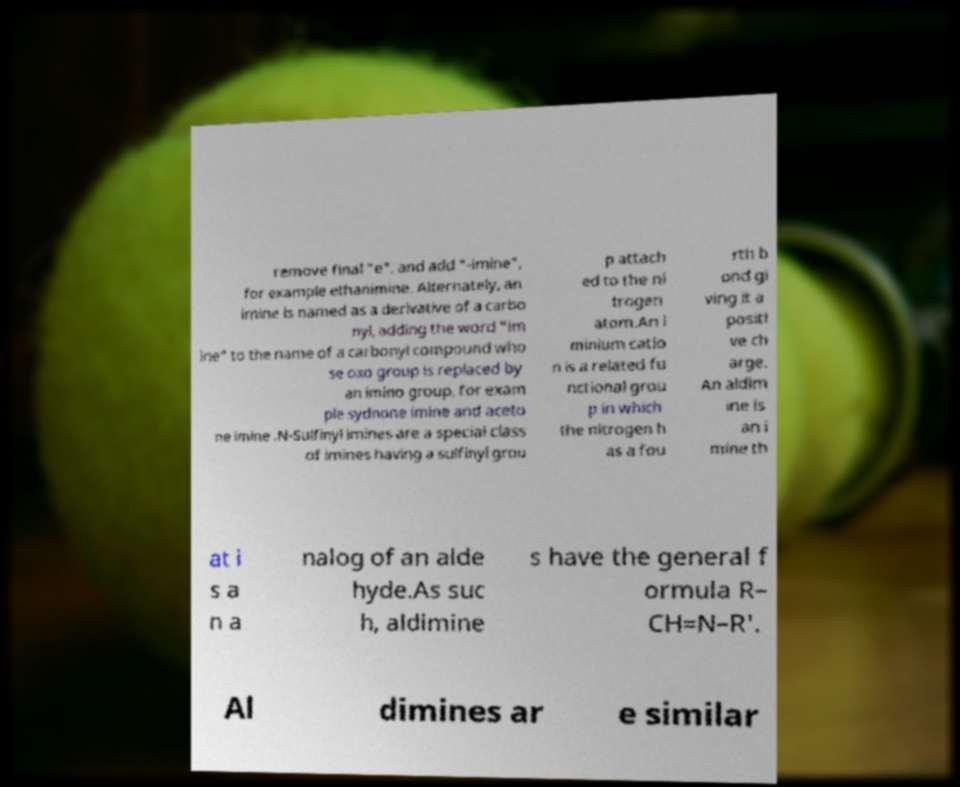Can you accurately transcribe the text from the provided image for me? remove final "e", and add "-imine", for example ethanimine. Alternately, an imine is named as a derivative of a carbo nyl, adding the word "im ine" to the name of a carbonyl compound who se oxo group is replaced by an imino group, for exam ple sydnone imine and aceto ne imine .N-Sulfinyl imines are a special class of imines having a sulfinyl grou p attach ed to the ni trogen atom.An i minium catio n is a related fu nctional grou p in which the nitrogen h as a fou rth b ond gi ving it a positi ve ch arge. An aldim ine is an i mine th at i s a n a nalog of an alde hyde.As suc h, aldimine s have the general f ormula R– CH=N–R'. Al dimines ar e similar 